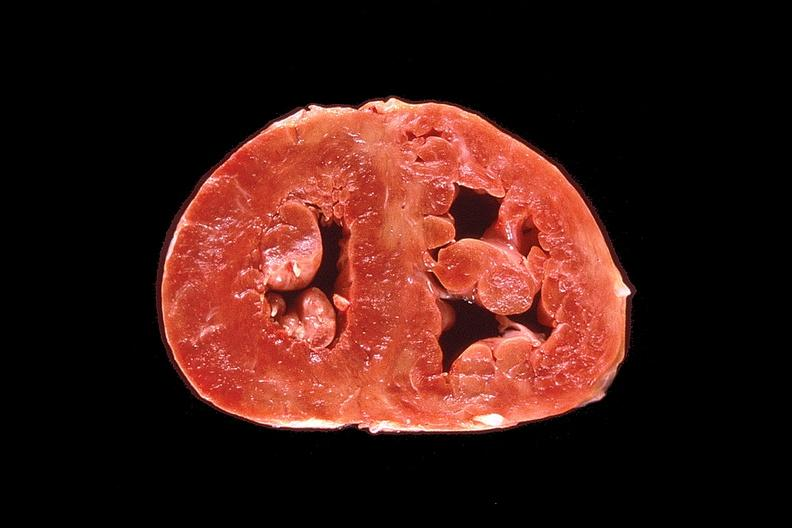does this image show heart, marked right ventricular hypertrophy due to pulmonary hypertension?
Answer the question using a single word or phrase. Yes 